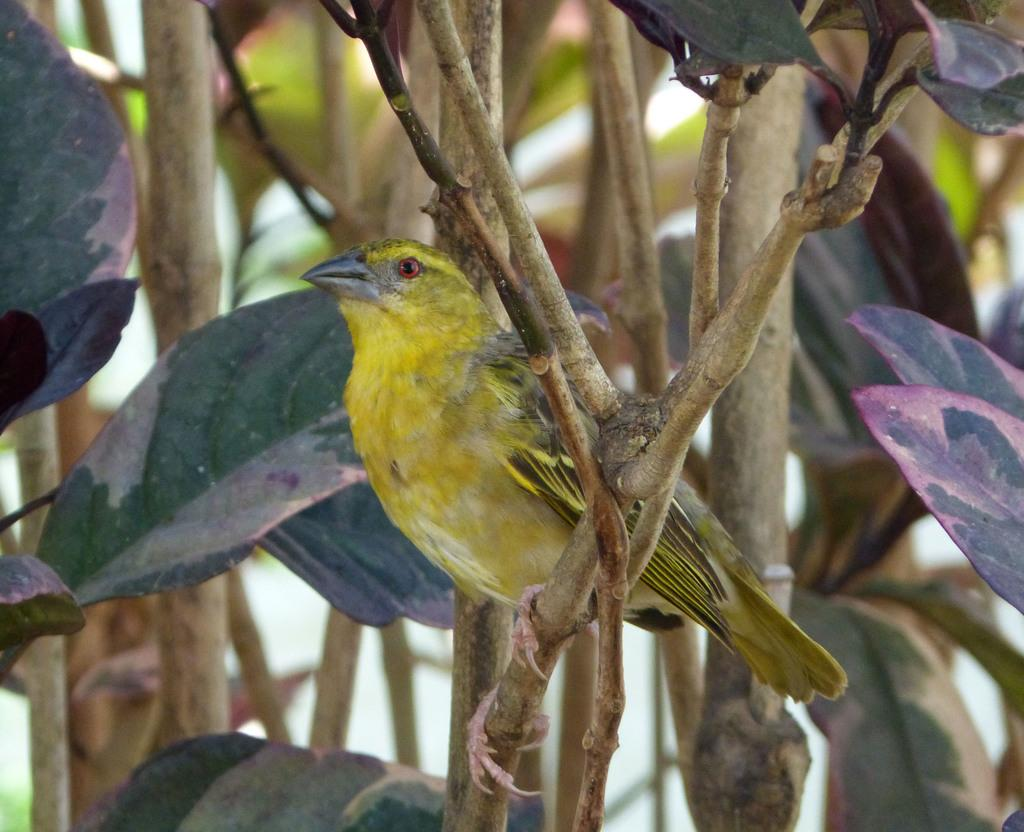What type of animal is in the image? There is a yellow bird in the image. Where is the bird located? The bird is sitting on the stem of a tree. What can be seen in the background of the image? There are many leaves visible in the image. What type of table is visible in the image? There is no table present in the image; it features a yellow bird sitting on the stem of a tree. Can you provide a list of all the items in the image? Based on the provided facts, there is a yellow bird, a tree stem, and leaves visible in the image. 